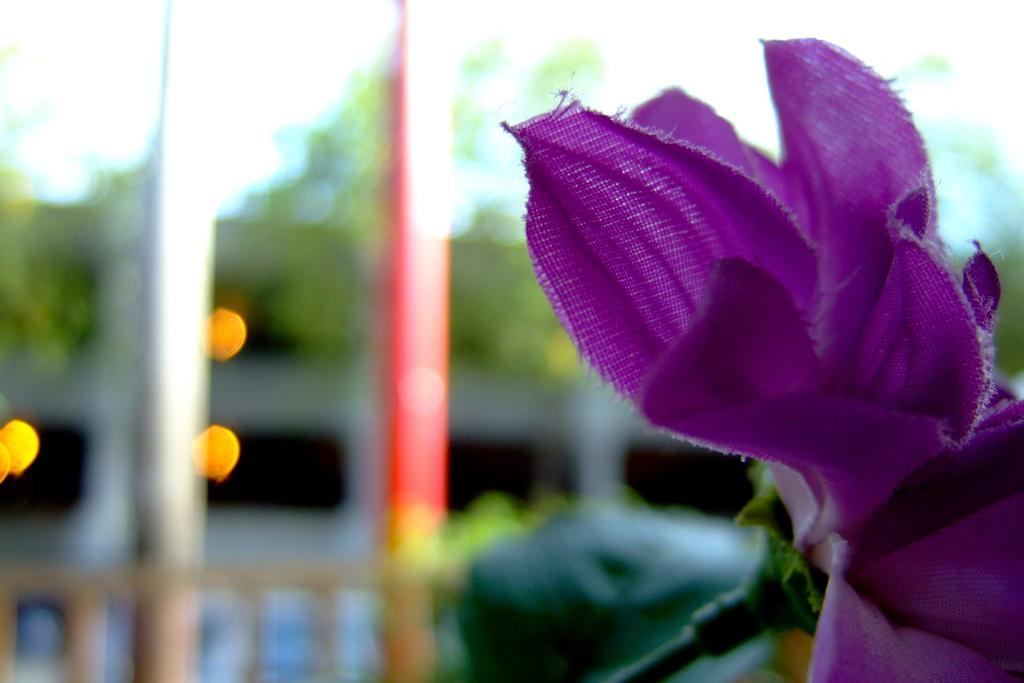What type of object is on the right side of the image? There is a purple color artificial flower on the right side of the image. Can you describe the background of the image? The background of the image is blurred. How many eyes can be seen on the flower in the image? There are no eyes visible on the flower in the image, as it is an artificial flower and not a living organism. 